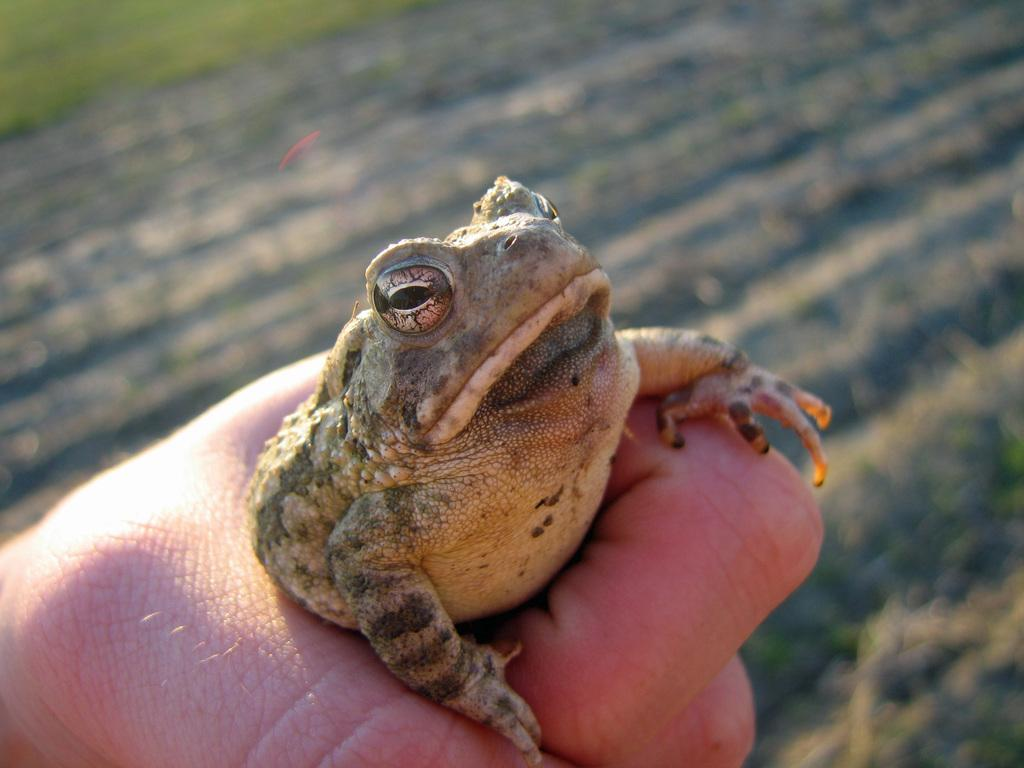Who or what is the main subject in the image? There is a person in the image. What is the person holding in the image? The person is holding a frog. Can you describe the frog's appearance? The frog is in black and cream color. What can be seen in the background of the image? There is grass in the background of the image. How would you describe the background's appearance? The background is blurry. How many houses can be seen in the image? There are no houses visible in the image. What type of spark can be seen coming from the frog in the image? There is no spark present in the image; the frog is in black and cream color and is being held by a person. 